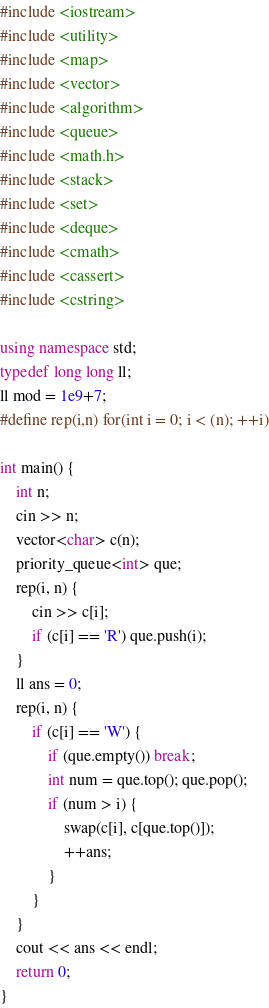<code> <loc_0><loc_0><loc_500><loc_500><_C++_>#include <iostream>
#include <utility>
#include <map>
#include <vector>
#include <algorithm>
#include <queue>
#include <math.h>
#include <stack>
#include <set>
#include <deque>
#include <cmath>
#include <cassert>
#include <cstring>

using namespace std;
typedef long long ll;
ll mod = 1e9+7;
#define rep(i,n) for(int i = 0; i < (n); ++i)

int main() {
    int n;
    cin >> n;
    vector<char> c(n);
    priority_queue<int> que;    
    rep(i, n) {
        cin >> c[i];
        if (c[i] == 'R') que.push(i);
    }
    ll ans = 0;
    rep(i, n) {
        if (c[i] == 'W') {
            if (que.empty()) break;
            int num = que.top(); que.pop();
            if (num > i) {
                swap(c[i], c[que.top()]);
                ++ans;
            }
        }
    }
    cout << ans << endl;
    return 0;
}
</code> 